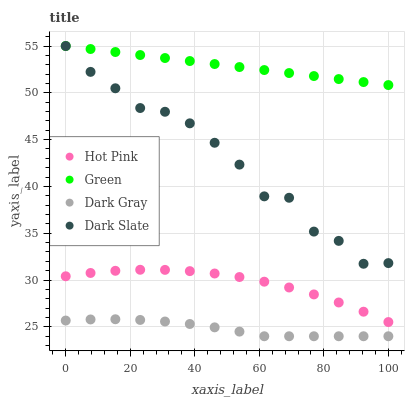Does Dark Gray have the minimum area under the curve?
Answer yes or no. Yes. Does Green have the maximum area under the curve?
Answer yes or no. Yes. Does Dark Slate have the minimum area under the curve?
Answer yes or no. No. Does Dark Slate have the maximum area under the curve?
Answer yes or no. No. Is Green the smoothest?
Answer yes or no. Yes. Is Dark Slate the roughest?
Answer yes or no. Yes. Is Hot Pink the smoothest?
Answer yes or no. No. Is Hot Pink the roughest?
Answer yes or no. No. Does Dark Gray have the lowest value?
Answer yes or no. Yes. Does Dark Slate have the lowest value?
Answer yes or no. No. Does Green have the highest value?
Answer yes or no. Yes. Does Hot Pink have the highest value?
Answer yes or no. No. Is Dark Gray less than Hot Pink?
Answer yes or no. Yes. Is Dark Slate greater than Dark Gray?
Answer yes or no. Yes. Does Green intersect Dark Slate?
Answer yes or no. Yes. Is Green less than Dark Slate?
Answer yes or no. No. Is Green greater than Dark Slate?
Answer yes or no. No. Does Dark Gray intersect Hot Pink?
Answer yes or no. No. 